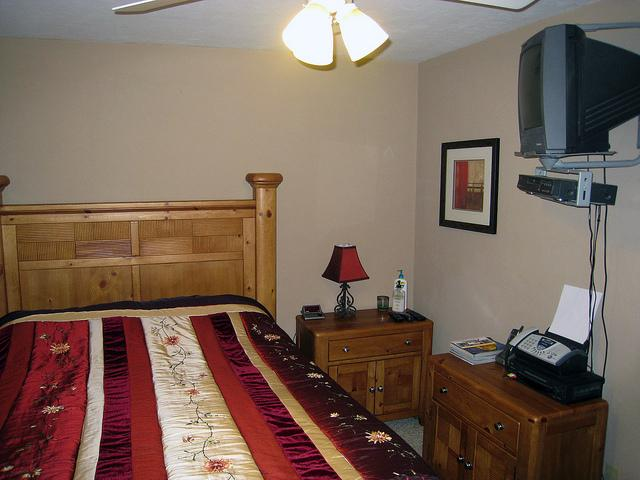What color is the main stripe on the right side of the queen sized bed? Please explain your reasoning. red. It is the biggest one on this side 